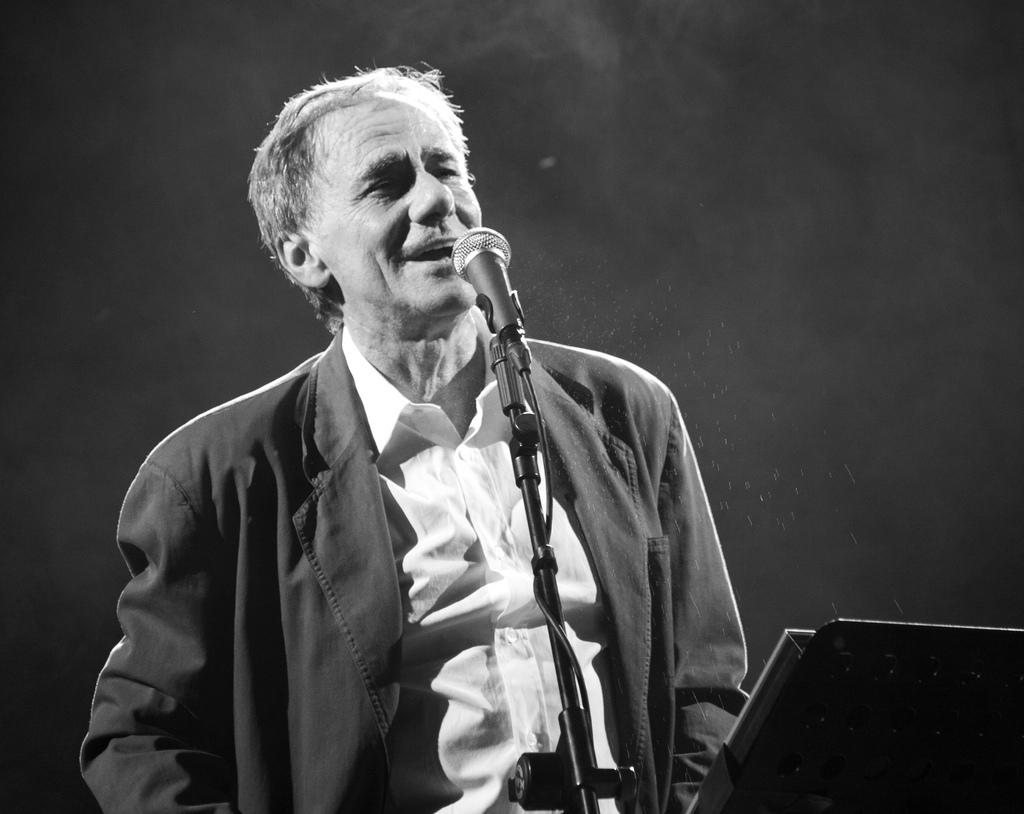What is the person in the image doing? There is a person standing at the mic in the image. What can be seen behind the person in the image? There is a wall in the background of the image. What type of dog is sitting next to the person at the mic in the image? There is no dog present in the image; it only features a person standing at the mic and a wall in the background. 